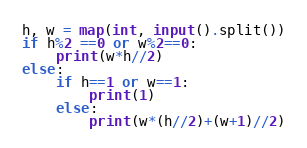Convert code to text. <code><loc_0><loc_0><loc_500><loc_500><_Python_>h, w = map(int, input().split())
if h%2 ==0 or w%2==0:
    print(w*h//2)
else:
    if h==1 or w==1:
        print(1)
    else:
        print(w*(h//2)+(w+1)//2)</code> 